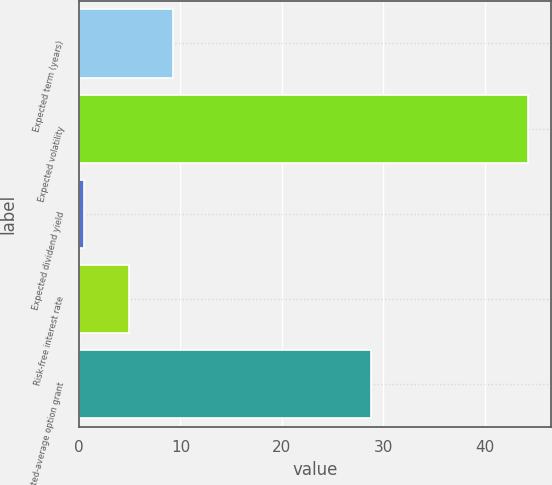<chart> <loc_0><loc_0><loc_500><loc_500><bar_chart><fcel>Expected term (years)<fcel>Expected volatility<fcel>Expected dividend yield<fcel>Risk-free interest rate<fcel>Weighted-average option grant<nl><fcel>9.28<fcel>44.3<fcel>0.52<fcel>4.9<fcel>28.84<nl></chart> 